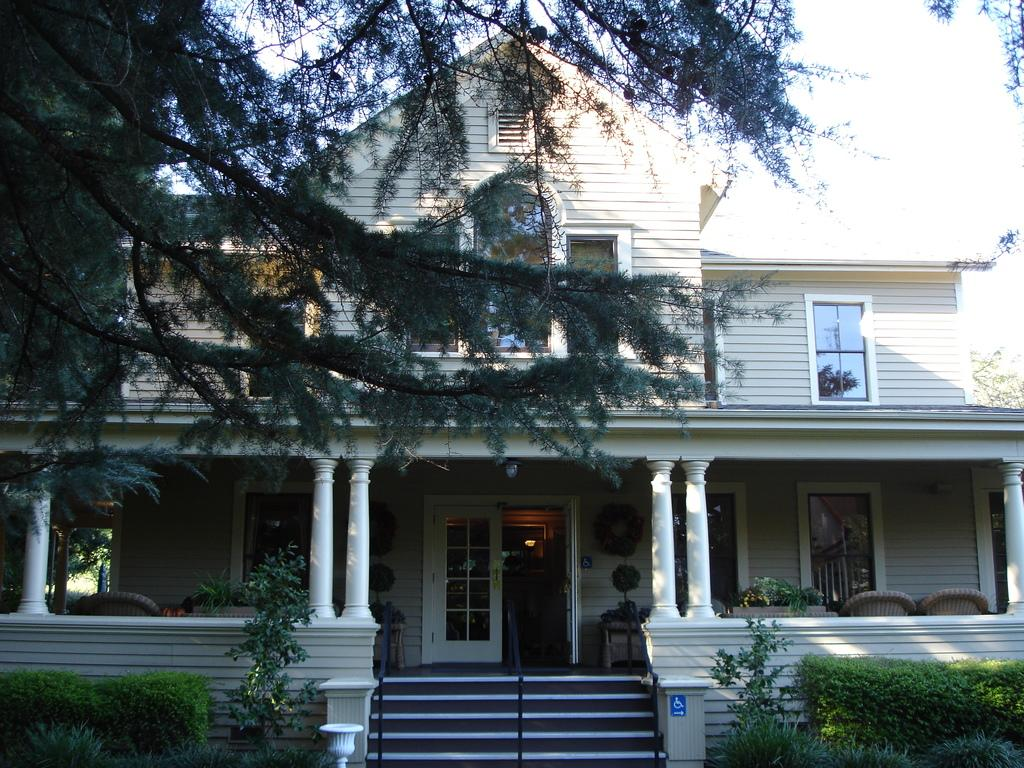What type of vegetation can be seen on both sides of the image? There are trees on the left side and the right side of the image. What type of furniture is present in the image? There are chairs in the image. What architectural feature is located in the middle of the image? There are stairs and a building in the middle of the image. What is the source of illumination in the image? There is a light in the middle of the image. Where is the pin located in the image? There is no pin present in the image. Is there a prison visible in the image? No, there is no prison present in the image. 